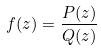<formula> <loc_0><loc_0><loc_500><loc_500>f ( z ) = \frac { P ( z ) } { Q ( z ) }</formula> 